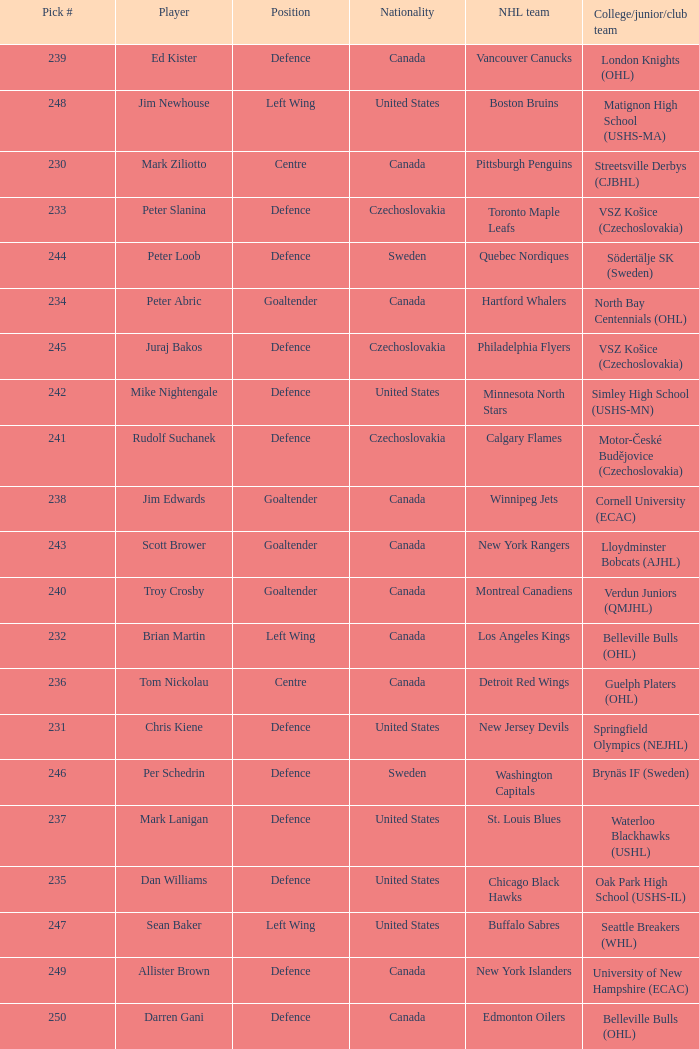Can you give me this table as a dict? {'header': ['Pick #', 'Player', 'Position', 'Nationality', 'NHL team', 'College/junior/club team'], 'rows': [['239', 'Ed Kister', 'Defence', 'Canada', 'Vancouver Canucks', 'London Knights (OHL)'], ['248', 'Jim Newhouse', 'Left Wing', 'United States', 'Boston Bruins', 'Matignon High School (USHS-MA)'], ['230', 'Mark Ziliotto', 'Centre', 'Canada', 'Pittsburgh Penguins', 'Streetsville Derbys (CJBHL)'], ['233', 'Peter Slanina', 'Defence', 'Czechoslovakia', 'Toronto Maple Leafs', 'VSZ Košice (Czechoslovakia)'], ['244', 'Peter Loob', 'Defence', 'Sweden', 'Quebec Nordiques', 'Södertälje SK (Sweden)'], ['234', 'Peter Abric', 'Goaltender', 'Canada', 'Hartford Whalers', 'North Bay Centennials (OHL)'], ['245', 'Juraj Bakos', 'Defence', 'Czechoslovakia', 'Philadelphia Flyers', 'VSZ Košice (Czechoslovakia)'], ['242', 'Mike Nightengale', 'Defence', 'United States', 'Minnesota North Stars', 'Simley High School (USHS-MN)'], ['241', 'Rudolf Suchanek', 'Defence', 'Czechoslovakia', 'Calgary Flames', 'Motor-České Budějovice (Czechoslovakia)'], ['238', 'Jim Edwards', 'Goaltender', 'Canada', 'Winnipeg Jets', 'Cornell University (ECAC)'], ['243', 'Scott Brower', 'Goaltender', 'Canada', 'New York Rangers', 'Lloydminster Bobcats (AJHL)'], ['240', 'Troy Crosby', 'Goaltender', 'Canada', 'Montreal Canadiens', 'Verdun Juniors (QMJHL)'], ['232', 'Brian Martin', 'Left Wing', 'Canada', 'Los Angeles Kings', 'Belleville Bulls (OHL)'], ['236', 'Tom Nickolau', 'Centre', 'Canada', 'Detroit Red Wings', 'Guelph Platers (OHL)'], ['231', 'Chris Kiene', 'Defence', 'United States', 'New Jersey Devils', 'Springfield Olympics (NEJHL)'], ['246', 'Per Schedrin', 'Defence', 'Sweden', 'Washington Capitals', 'Brynäs IF (Sweden)'], ['237', 'Mark Lanigan', 'Defence', 'United States', 'St. Louis Blues', 'Waterloo Blackhawks (USHL)'], ['235', 'Dan Williams', 'Defence', 'United States', 'Chicago Black Hawks', 'Oak Park High School (USHS-IL)'], ['247', 'Sean Baker', 'Left Wing', 'United States', 'Buffalo Sabres', 'Seattle Breakers (WHL)'], ['249', 'Allister Brown', 'Defence', 'Canada', 'New York Islanders', 'University of New Hampshire (ECAC)'], ['250', 'Darren Gani', 'Defence', 'Canada', 'Edmonton Oilers', 'Belleville Bulls (OHL)']]} List the players for team brynäs if (sweden). Per Schedrin. 